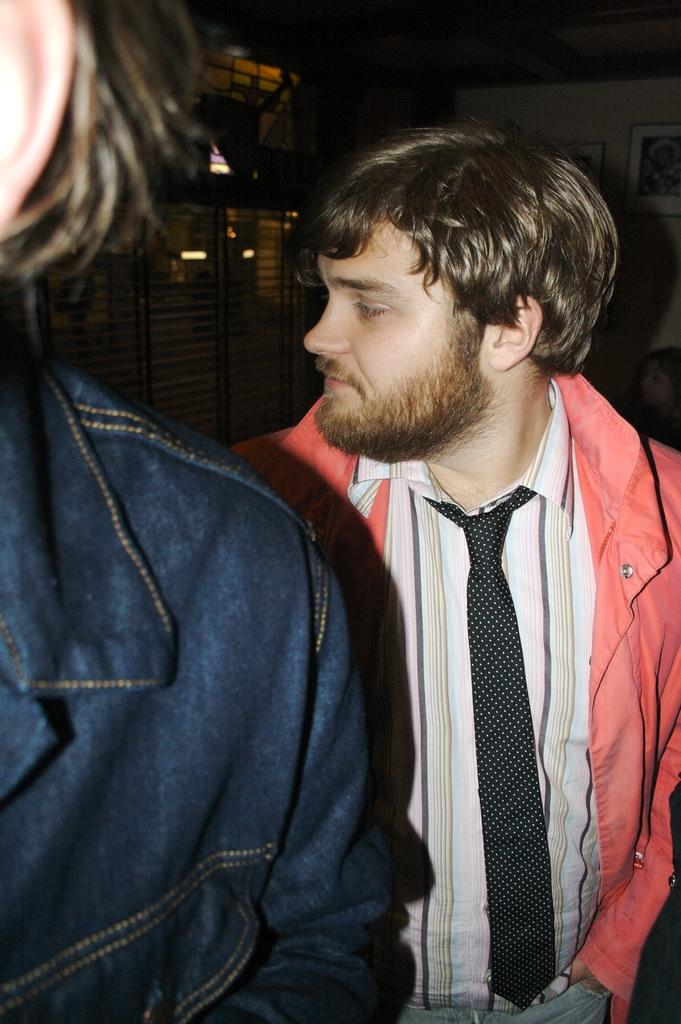How many people are in the image? There are two persons in the image. What can be seen in the background of the image? There is a fence and a wall in the background of the image. What is on the wall in the image? There is a photo frame on the wall. Where is one of the persons located in relation to the wall? There is a person in front of the wall. What type of celery is being used as a prop in the image? There is no celery present in the image. How comfortable are the horses in the image? There are no horses present in the image. 